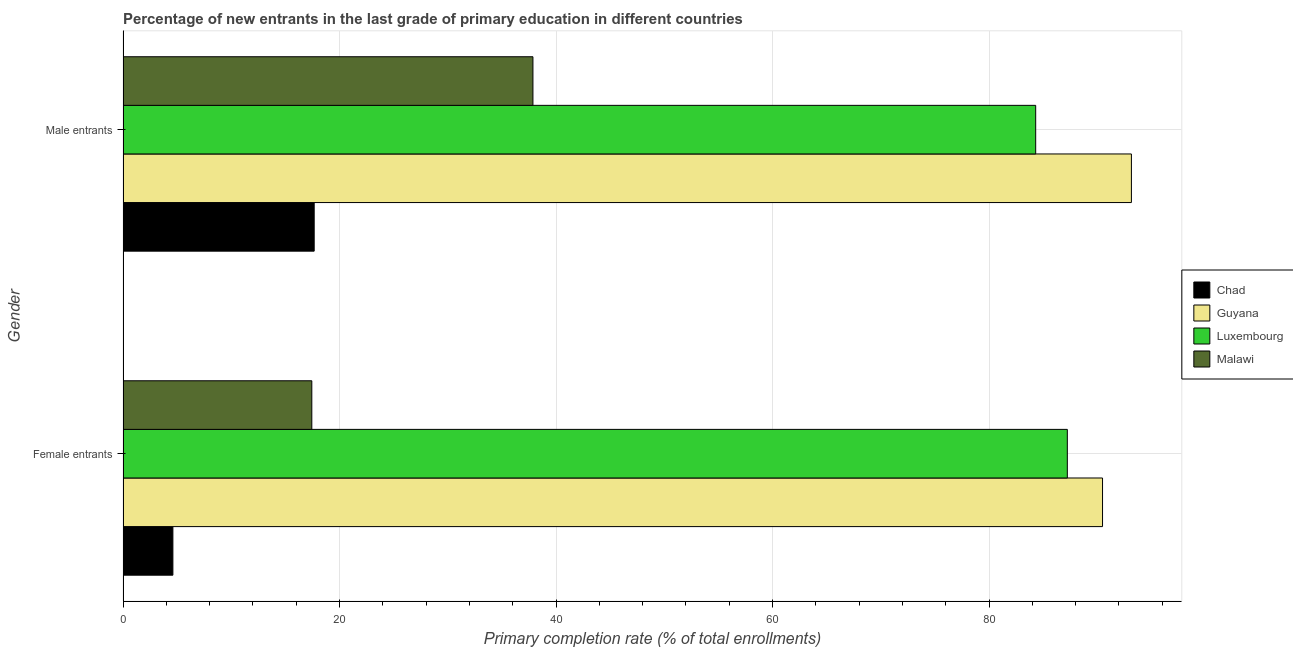How many different coloured bars are there?
Your answer should be compact. 4. How many groups of bars are there?
Provide a short and direct response. 2. Are the number of bars on each tick of the Y-axis equal?
Give a very brief answer. Yes. What is the label of the 1st group of bars from the top?
Provide a succinct answer. Male entrants. What is the primary completion rate of female entrants in Chad?
Offer a terse response. 4.61. Across all countries, what is the maximum primary completion rate of female entrants?
Offer a very short reply. 90.48. Across all countries, what is the minimum primary completion rate of male entrants?
Your response must be concise. 17.66. In which country was the primary completion rate of female entrants maximum?
Provide a short and direct response. Guyana. In which country was the primary completion rate of male entrants minimum?
Offer a terse response. Chad. What is the total primary completion rate of female entrants in the graph?
Provide a succinct answer. 199.77. What is the difference between the primary completion rate of male entrants in Chad and that in Guyana?
Your response must be concise. -75.49. What is the difference between the primary completion rate of male entrants in Guyana and the primary completion rate of female entrants in Chad?
Give a very brief answer. 88.54. What is the average primary completion rate of male entrants per country?
Your answer should be compact. 58.25. What is the difference between the primary completion rate of male entrants and primary completion rate of female entrants in Luxembourg?
Provide a short and direct response. -2.92. What is the ratio of the primary completion rate of male entrants in Malawi to that in Chad?
Give a very brief answer. 2.14. In how many countries, is the primary completion rate of female entrants greater than the average primary completion rate of female entrants taken over all countries?
Your answer should be compact. 2. What does the 2nd bar from the top in Male entrants represents?
Provide a short and direct response. Luxembourg. What does the 3rd bar from the bottom in Male entrants represents?
Ensure brevity in your answer.  Luxembourg. How many countries are there in the graph?
Provide a succinct answer. 4. Are the values on the major ticks of X-axis written in scientific E-notation?
Provide a short and direct response. No. Does the graph contain any zero values?
Your answer should be very brief. No. Does the graph contain grids?
Provide a short and direct response. Yes. What is the title of the graph?
Provide a short and direct response. Percentage of new entrants in the last grade of primary education in different countries. What is the label or title of the X-axis?
Make the answer very short. Primary completion rate (% of total enrollments). What is the label or title of the Y-axis?
Keep it short and to the point. Gender. What is the Primary completion rate (% of total enrollments) of Chad in Female entrants?
Your response must be concise. 4.61. What is the Primary completion rate (% of total enrollments) of Guyana in Female entrants?
Offer a very short reply. 90.48. What is the Primary completion rate (% of total enrollments) in Luxembourg in Female entrants?
Your answer should be compact. 87.23. What is the Primary completion rate (% of total enrollments) of Malawi in Female entrants?
Your answer should be compact. 17.44. What is the Primary completion rate (% of total enrollments) of Chad in Male entrants?
Your response must be concise. 17.66. What is the Primary completion rate (% of total enrollments) in Guyana in Male entrants?
Your answer should be compact. 93.15. What is the Primary completion rate (% of total enrollments) in Luxembourg in Male entrants?
Provide a succinct answer. 84.31. What is the Primary completion rate (% of total enrollments) of Malawi in Male entrants?
Make the answer very short. 37.87. Across all Gender, what is the maximum Primary completion rate (% of total enrollments) in Chad?
Your answer should be very brief. 17.66. Across all Gender, what is the maximum Primary completion rate (% of total enrollments) of Guyana?
Give a very brief answer. 93.15. Across all Gender, what is the maximum Primary completion rate (% of total enrollments) of Luxembourg?
Your response must be concise. 87.23. Across all Gender, what is the maximum Primary completion rate (% of total enrollments) in Malawi?
Provide a succinct answer. 37.87. Across all Gender, what is the minimum Primary completion rate (% of total enrollments) in Chad?
Give a very brief answer. 4.61. Across all Gender, what is the minimum Primary completion rate (% of total enrollments) of Guyana?
Your answer should be very brief. 90.48. Across all Gender, what is the minimum Primary completion rate (% of total enrollments) of Luxembourg?
Ensure brevity in your answer.  84.31. Across all Gender, what is the minimum Primary completion rate (% of total enrollments) of Malawi?
Provide a short and direct response. 17.44. What is the total Primary completion rate (% of total enrollments) of Chad in the graph?
Make the answer very short. 22.27. What is the total Primary completion rate (% of total enrollments) in Guyana in the graph?
Your answer should be very brief. 183.63. What is the total Primary completion rate (% of total enrollments) of Luxembourg in the graph?
Your response must be concise. 171.54. What is the total Primary completion rate (% of total enrollments) of Malawi in the graph?
Provide a succinct answer. 55.31. What is the difference between the Primary completion rate (% of total enrollments) in Chad in Female entrants and that in Male entrants?
Make the answer very short. -13.05. What is the difference between the Primary completion rate (% of total enrollments) in Guyana in Female entrants and that in Male entrants?
Make the answer very short. -2.67. What is the difference between the Primary completion rate (% of total enrollments) of Luxembourg in Female entrants and that in Male entrants?
Provide a succinct answer. 2.92. What is the difference between the Primary completion rate (% of total enrollments) in Malawi in Female entrants and that in Male entrants?
Make the answer very short. -20.43. What is the difference between the Primary completion rate (% of total enrollments) in Chad in Female entrants and the Primary completion rate (% of total enrollments) in Guyana in Male entrants?
Provide a short and direct response. -88.54. What is the difference between the Primary completion rate (% of total enrollments) in Chad in Female entrants and the Primary completion rate (% of total enrollments) in Luxembourg in Male entrants?
Your answer should be compact. -79.7. What is the difference between the Primary completion rate (% of total enrollments) of Chad in Female entrants and the Primary completion rate (% of total enrollments) of Malawi in Male entrants?
Offer a very short reply. -33.26. What is the difference between the Primary completion rate (% of total enrollments) of Guyana in Female entrants and the Primary completion rate (% of total enrollments) of Luxembourg in Male entrants?
Offer a terse response. 6.17. What is the difference between the Primary completion rate (% of total enrollments) of Guyana in Female entrants and the Primary completion rate (% of total enrollments) of Malawi in Male entrants?
Offer a very short reply. 52.61. What is the difference between the Primary completion rate (% of total enrollments) in Luxembourg in Female entrants and the Primary completion rate (% of total enrollments) in Malawi in Male entrants?
Give a very brief answer. 49.36. What is the average Primary completion rate (% of total enrollments) in Chad per Gender?
Your answer should be very brief. 11.13. What is the average Primary completion rate (% of total enrollments) of Guyana per Gender?
Offer a terse response. 91.82. What is the average Primary completion rate (% of total enrollments) of Luxembourg per Gender?
Ensure brevity in your answer.  85.77. What is the average Primary completion rate (% of total enrollments) in Malawi per Gender?
Provide a succinct answer. 27.66. What is the difference between the Primary completion rate (% of total enrollments) in Chad and Primary completion rate (% of total enrollments) in Guyana in Female entrants?
Your answer should be very brief. -85.87. What is the difference between the Primary completion rate (% of total enrollments) of Chad and Primary completion rate (% of total enrollments) of Luxembourg in Female entrants?
Provide a succinct answer. -82.62. What is the difference between the Primary completion rate (% of total enrollments) in Chad and Primary completion rate (% of total enrollments) in Malawi in Female entrants?
Offer a very short reply. -12.83. What is the difference between the Primary completion rate (% of total enrollments) of Guyana and Primary completion rate (% of total enrollments) of Luxembourg in Female entrants?
Give a very brief answer. 3.25. What is the difference between the Primary completion rate (% of total enrollments) in Guyana and Primary completion rate (% of total enrollments) in Malawi in Female entrants?
Your answer should be compact. 73.04. What is the difference between the Primary completion rate (% of total enrollments) of Luxembourg and Primary completion rate (% of total enrollments) of Malawi in Female entrants?
Provide a succinct answer. 69.79. What is the difference between the Primary completion rate (% of total enrollments) in Chad and Primary completion rate (% of total enrollments) in Guyana in Male entrants?
Offer a very short reply. -75.49. What is the difference between the Primary completion rate (% of total enrollments) of Chad and Primary completion rate (% of total enrollments) of Luxembourg in Male entrants?
Provide a short and direct response. -66.65. What is the difference between the Primary completion rate (% of total enrollments) in Chad and Primary completion rate (% of total enrollments) in Malawi in Male entrants?
Offer a very short reply. -20.21. What is the difference between the Primary completion rate (% of total enrollments) of Guyana and Primary completion rate (% of total enrollments) of Luxembourg in Male entrants?
Make the answer very short. 8.84. What is the difference between the Primary completion rate (% of total enrollments) in Guyana and Primary completion rate (% of total enrollments) in Malawi in Male entrants?
Keep it short and to the point. 55.28. What is the difference between the Primary completion rate (% of total enrollments) of Luxembourg and Primary completion rate (% of total enrollments) of Malawi in Male entrants?
Give a very brief answer. 46.44. What is the ratio of the Primary completion rate (% of total enrollments) in Chad in Female entrants to that in Male entrants?
Your response must be concise. 0.26. What is the ratio of the Primary completion rate (% of total enrollments) of Guyana in Female entrants to that in Male entrants?
Provide a short and direct response. 0.97. What is the ratio of the Primary completion rate (% of total enrollments) in Luxembourg in Female entrants to that in Male entrants?
Your answer should be very brief. 1.03. What is the ratio of the Primary completion rate (% of total enrollments) of Malawi in Female entrants to that in Male entrants?
Give a very brief answer. 0.46. What is the difference between the highest and the second highest Primary completion rate (% of total enrollments) of Chad?
Give a very brief answer. 13.05. What is the difference between the highest and the second highest Primary completion rate (% of total enrollments) in Guyana?
Your answer should be very brief. 2.67. What is the difference between the highest and the second highest Primary completion rate (% of total enrollments) in Luxembourg?
Offer a very short reply. 2.92. What is the difference between the highest and the second highest Primary completion rate (% of total enrollments) in Malawi?
Ensure brevity in your answer.  20.43. What is the difference between the highest and the lowest Primary completion rate (% of total enrollments) in Chad?
Keep it short and to the point. 13.05. What is the difference between the highest and the lowest Primary completion rate (% of total enrollments) of Guyana?
Ensure brevity in your answer.  2.67. What is the difference between the highest and the lowest Primary completion rate (% of total enrollments) of Luxembourg?
Provide a short and direct response. 2.92. What is the difference between the highest and the lowest Primary completion rate (% of total enrollments) of Malawi?
Your response must be concise. 20.43. 